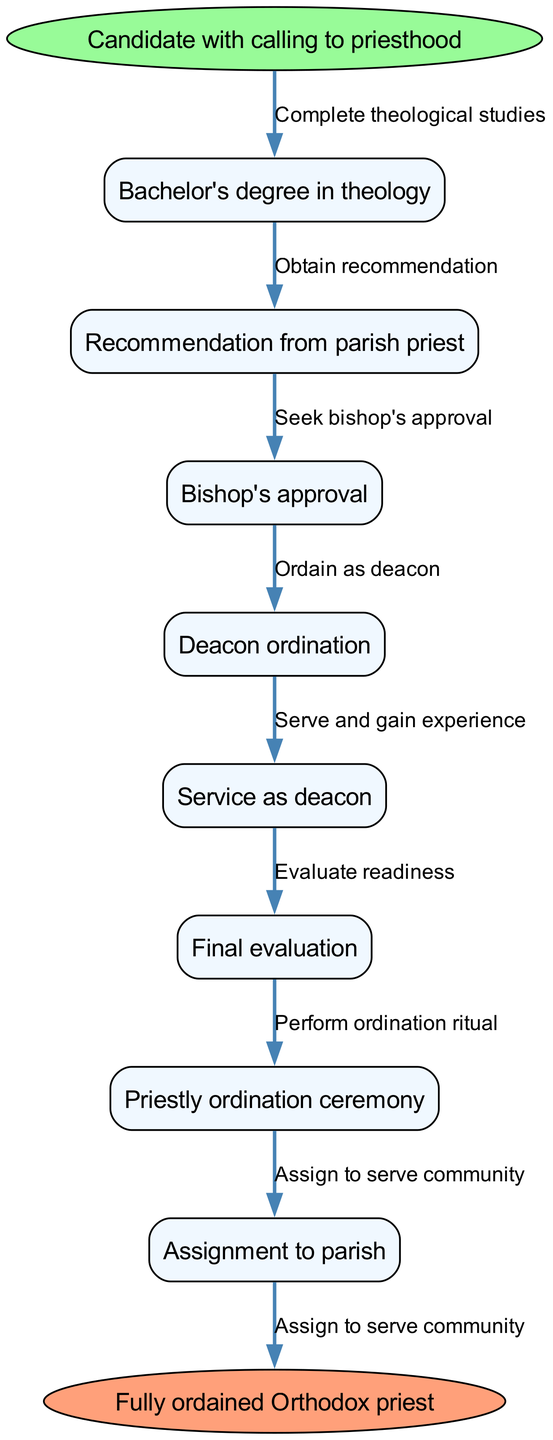What is the starting point of the ordination process? The starting point is the candidate who has a calling to priesthood as indicated in the diagram.
Answer: Candidate with calling to priesthood How many nodes are present in the diagram? The diagram has a total of 8 nodes, which include the start node, 6 intermediate steps, and the end node.
Answer: 8 What follows the Bachelor's degree in theology? After obtaining the Bachelor's degree in theology, the next step is to obtain a recommendation from the parish priest.
Answer: Recommendation from parish priest What is the final step in the process? The final step in the process of ordination is the assignment to a parish after ordination is complete.
Answer: Assignment to parish How many edges connect the nodes in this diagram? The diagram features 7 edges that connect the nodes representing the steps in the ordination process.
Answer: 7 What is the first action that follows the candidate's calling to priesthood? The first action that follows the candidate's calling is to complete the Bachelor's degree in theology.
Answer: Complete theological studies Which node represents the bishop's approval? The node representing the bishop's approval is directly labeled as "Bishop's approval."
Answer: Bishop's approval What are the two nodes connected directly to "Service as deacon"? The nodes connected directly to "Service as deacon" are "Deacon ordination" and "Final evaluation."
Answer: Deacon ordination and Final evaluation Which node comes immediately before the "Priestly ordination ceremony"? The node that comes immediately before the "Priestly ordination ceremony" is "Final evaluation."
Answer: Final evaluation What connects "Deacon ordination" and "Service as deacon"? The edge that connects "Deacon ordination" and "Service as deacon" is labeled "Serve and gain experience."
Answer: Serve and gain experience 